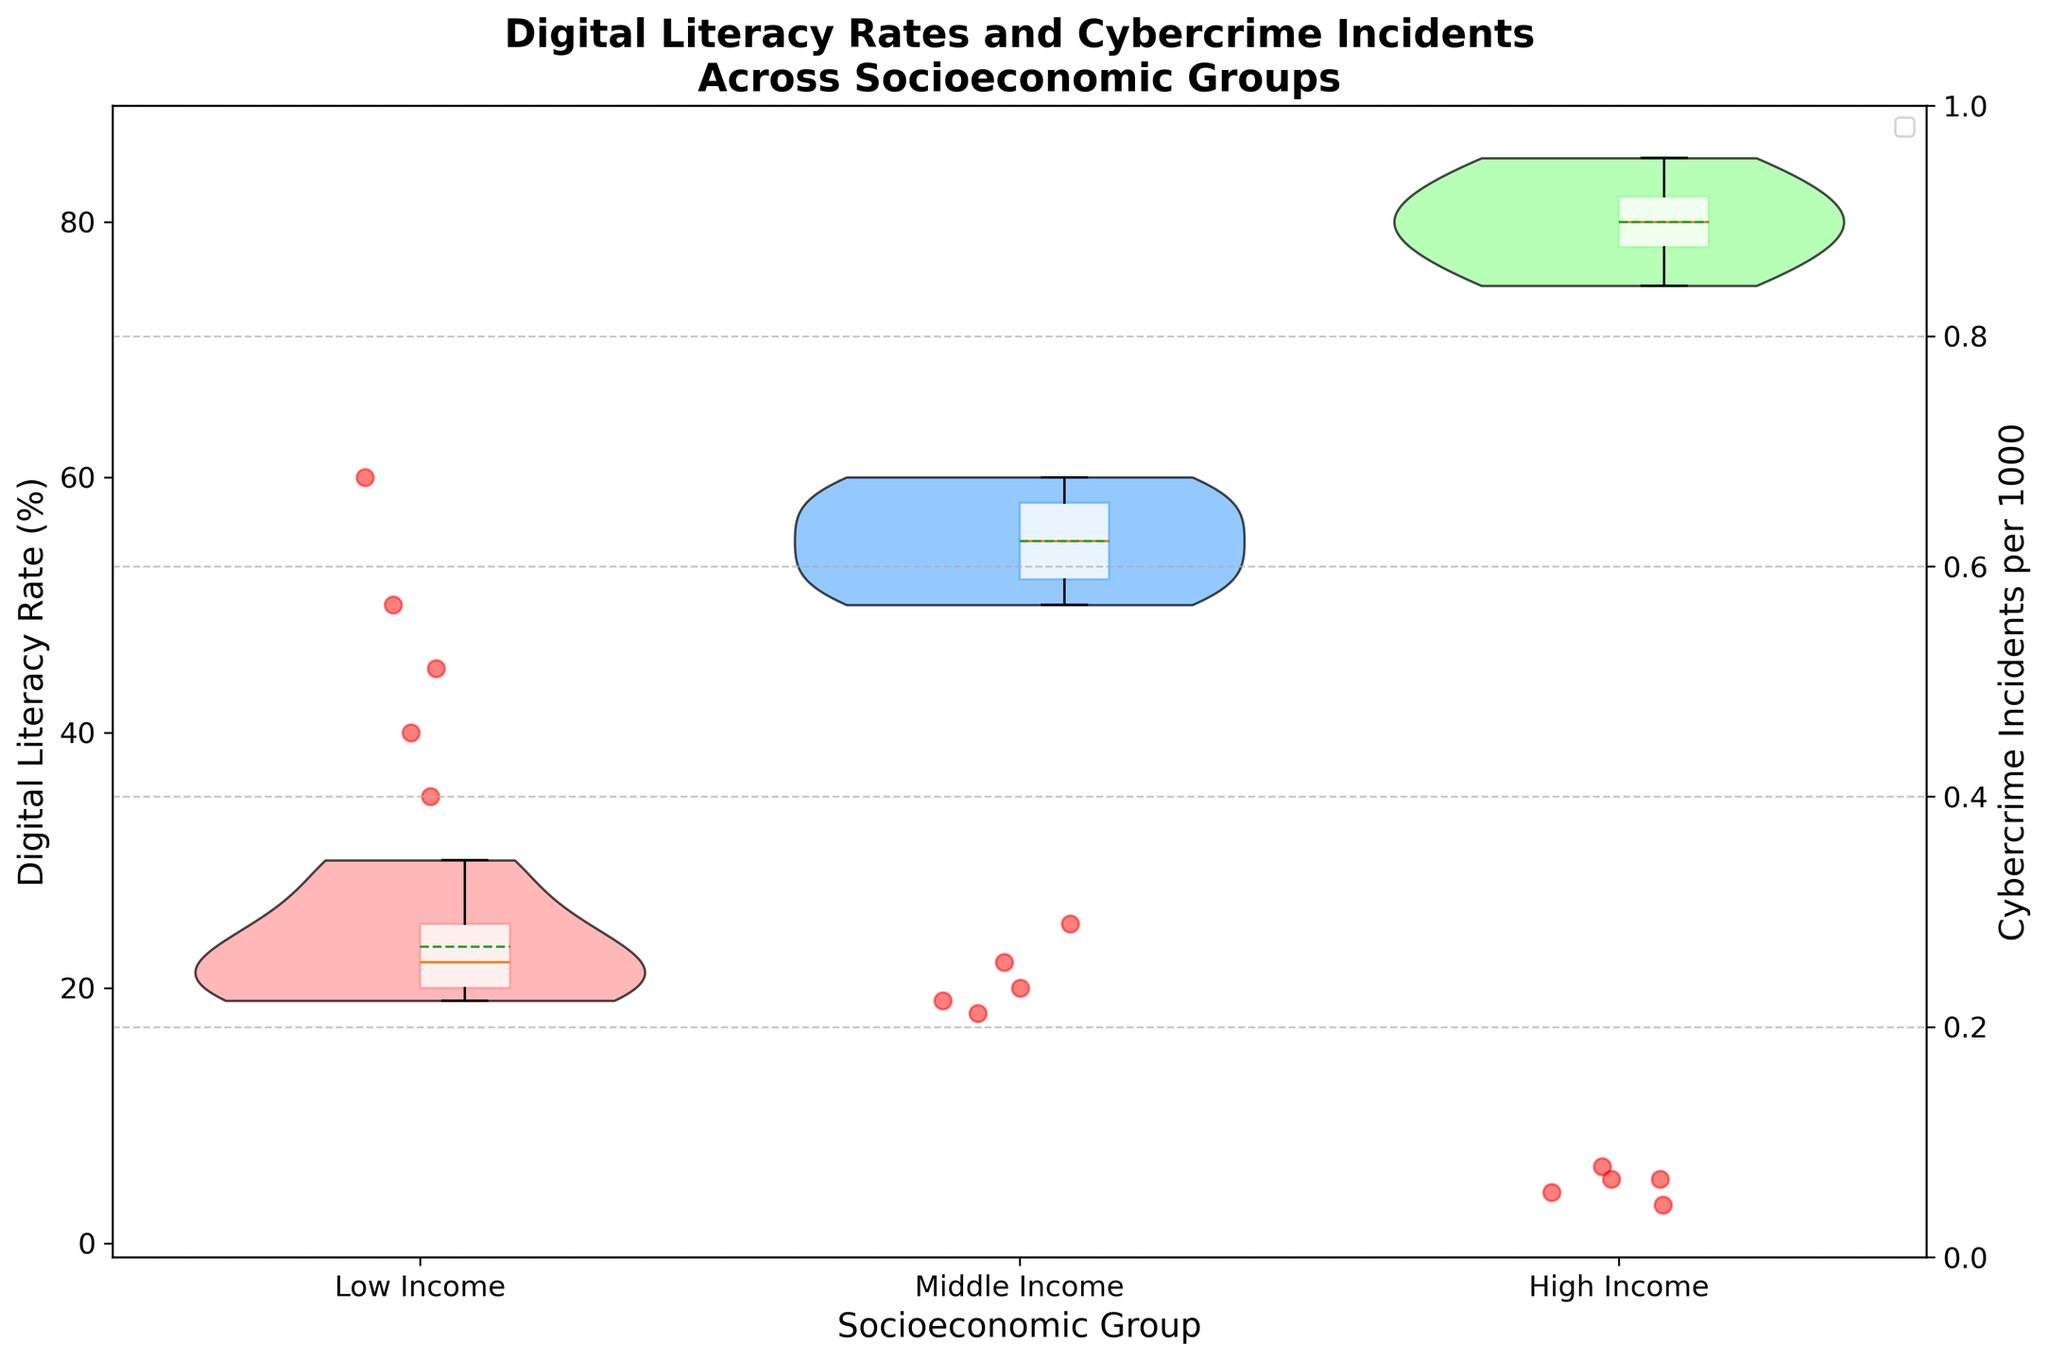What does the title of the chart suggest about its content? The title of the chart is "Digital Literacy Rates and Cybercrime Incidents Across Socioeconomic Groups," which indicates that the chart shows the digital literacy rates of different socioeconomic groups and their associated cybercrime incident rates.
Answer: Digital literacy rates and cybercrime incidents across socioeconomic groups What are the three socioeconomic groups represented in the chart? By looking at the x-axis labels, you can identify the three groups: Low Income, Middle Income, and High Income.
Answer: Low Income, Middle Income, High Income Which socioeconomic group has the lowest digital literacy rate? By examining the violin plots and box plots, it is clear that the Low Income group has the lowest digital literacy rate as it is positioned lower on the y-axis.
Answer: Low Income Which socioeconomic group has the highest number of cybercrime incidents? The scatter plot points representing cybercrime incidents indicate that the Low Income group has the highest number of incidents per 1000, as they are plotted at the highest positions on the secondary y-axis.
Answer: Low Income On average, how does the digital literacy rate of the High Income group compare to that of the Low Income group? The median values of the box plots can be compared to determine the central tendency. The High Income group has a much higher median digital literacy rate compared to the Low Income group.
Answer: High Income is higher What is the range of digital literacy rates for the Middle Income group? The range of values can be observed from the extremes of the violin and box plots for the Middle Income group. The minimum is around 50%, and the maximum is around 60%.
Answer: 50% to 60% Compare the spread of digital literacy rates between the Low Income and High Income groups. The length of the violin plots shows the spread. The Low Income group has a more extensive spread, indicating more variability, while the High Income group has a narrower spread, indicating less variability.
Answer: Low Income has more spread How do the number of cybercrime incidents correspond to the digital literacy rates across the groups? The scatter plot shows more cybercrime incidents are associated with lower digital literacy rates (Low Income group) and fewer incidents with higher digital literacy rates (High Income group).
Answer: Lower literacy, more incidents Which group shows the least variability in digital literacy rates? The High Income group's violin plot is the narrowest, indicating the least variability in digital literacy rates.
Answer: High Income What is the median digital literacy rate for the Low Income group? The median value is shown in the center of the box plot for the Low Income group. It appears to be around 22%.
Answer: 22% 